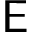Convert formula to latex. <formula><loc_0><loc_0><loc_500><loc_500>E</formula> 